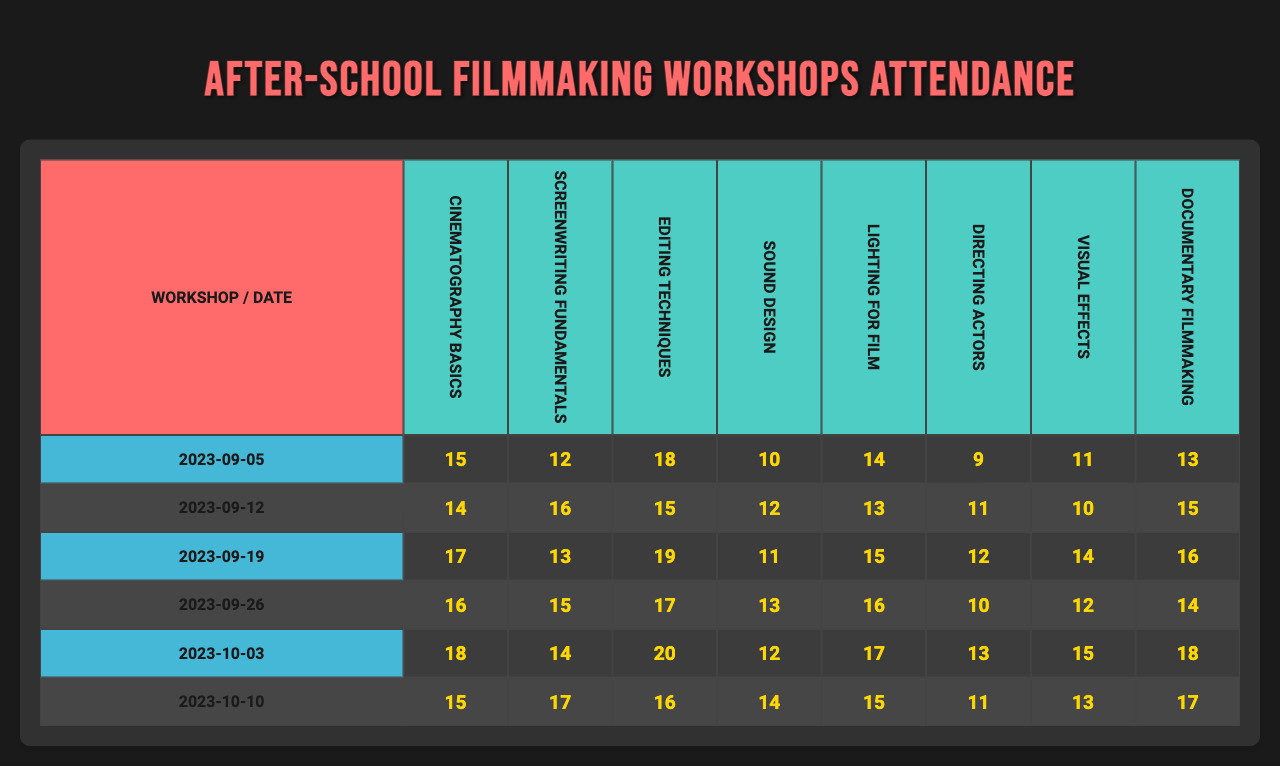What is the attendance for the "Editing Techniques" workshop on "2023-09-26"? Looking at the table, under the date "2023-09-26" in the "Editing Techniques" column, the attendance value is 11.
Answer: 11 Which workshop had the highest attendance on "2023-10-03"? For the date "2023-10-03", the attendance values for all workshops are gathered. The highest value among them is 20, which corresponds to the "Lighting for Film" workshop.
Answer: Lighting for Film What was the average attendance for the "Screenwriting Fundamentals" workshop? The attendance numbers for "Screenwriting Fundamentals" on the given dates are: 16, 12, 17, 15, 13, 11. Summing these values gives 84, and to find the average, divide by 6 (the number of dates). Thus, 84 / 6 = 14.
Answer: 14 Did the attendance for "Sound Design" ever drop below 10? The attendance for "Sound Design" on the dates are: 13, 12, 10, 16, 12, 11. None of these values are below 10. Therefore, the answer is no.
Answer: No What is the total attendance for all workshops on "2023-09-12"? On "2023-09-12", the attendances are 16 (Cinematography Basics), 16 (Screenwriting Fundamentals), 13 (Editing Techniques), 15 (Sound Design), 14 (Lighting for Film), 17 (Directing Actors). Summing these values: 16 + 16 + 13 + 15 + 14 + 17 = 91.
Answer: 91 Which workshop had the lowest attendance overall? By viewing the attendance values for each workshop across all dates, the lowest attendance recorded is 9, which is for "Directing Actors" on "2023-09-05".
Answer: Directing Actors What is the trend in attendance for "Documentary Filmmaking" over the workshop dates? The attendance numbers for "Documentary Filmmaking" are: 12, 15, 16, 14, 18, and 17. Observing these figures reveals variations but generally an upward trend, starting from 12 and ending at 17.
Answer: Generally increasing What is the difference in attendance between the "Cinematography Basics" workshop on "2023-09-05" and "2023-10-10"? The attendance on "2023-09-05" for "Cinematography Basics" is 15 and on "2023-10-10" is 17. The difference is 17 - 15 = 2.
Answer: 2 What is the median attendance for all workshops on "2023-10-03"? The attendance values for that date are 18, 13, 17, 12, 15, and 14. Arranging them gives: 12, 13, 14, 15, 17, 18. Since there are six values, the median is the average of the 3rd and 4th values: (14 + 15) / 2 = 14.5.
Answer: 14.5 On which date did the "Visual Effects" workshop have an attendance of 14? Referring to the table, the attendance for "Visual Effects" is checked against each date. It shows the value 14 on "2023-10-10".
Answer: 2023-10-10 